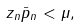Convert formula to latex. <formula><loc_0><loc_0><loc_500><loc_500>z _ { n } \bar { p } _ { n } < \mu ,</formula> 